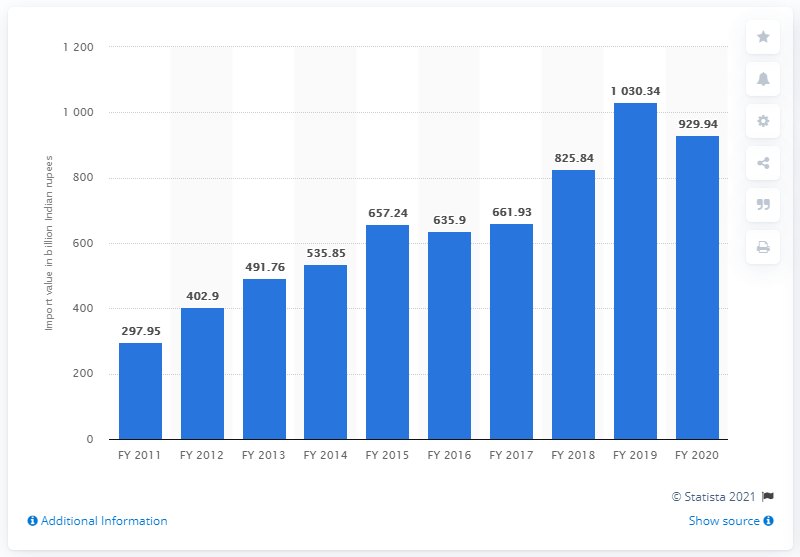Indicate a few pertinent items in this graphic. In fiscal year 2020, a total of 929.94 Indian rupees worth of non-ferrous metals were imported into India. 